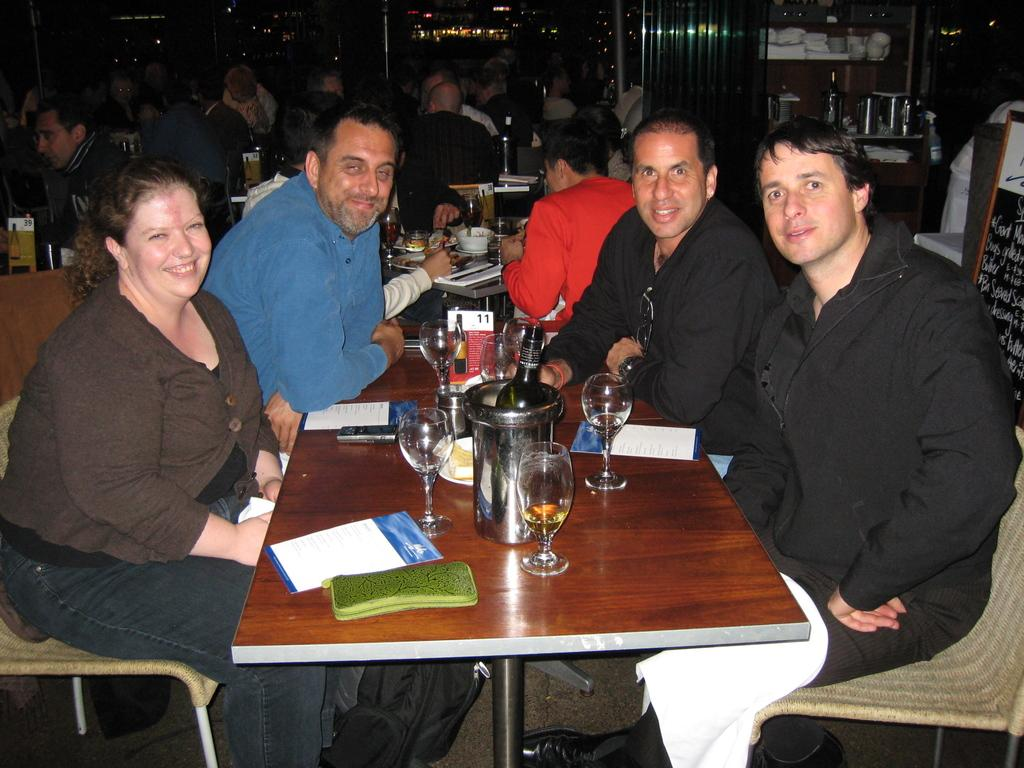How many people are in the image? There is a group of people in the image. What are the people doing in the image? The people are sitting on chairs. Where are the chairs located in relation to the table? The chairs are in front of a table. What can be seen on the table in the image? There are glasses and other objects on the table. What type of bait is being used by the women in the image? There are no women or bait present in the image. What beliefs do the people in the image hold about the objects on the table? The image does not provide information about the beliefs of the people in the image. 